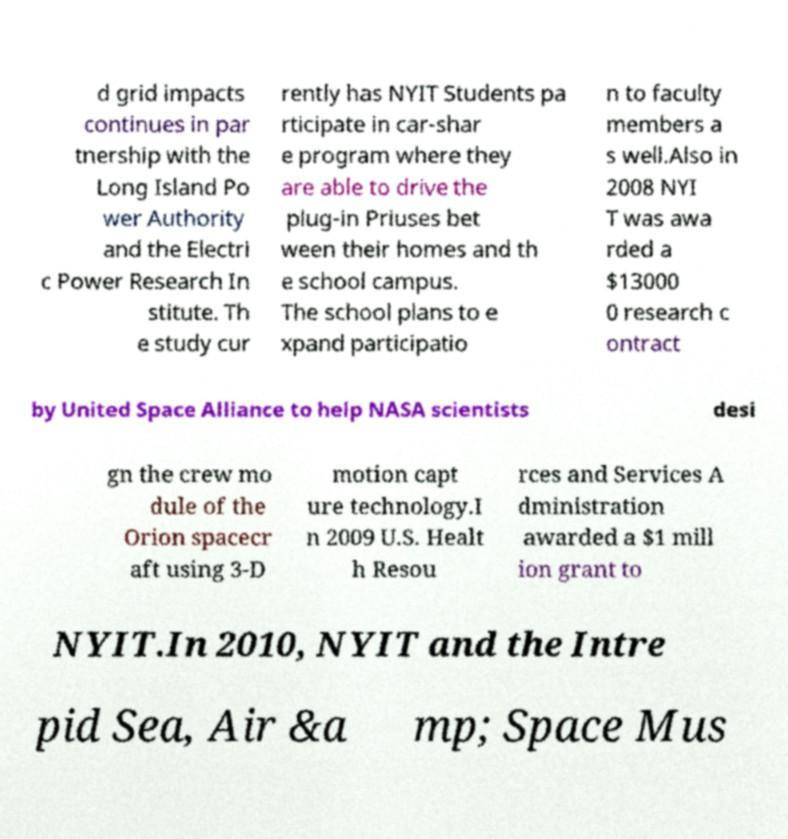Please read and relay the text visible in this image. What does it say? d grid impacts continues in par tnership with the Long Island Po wer Authority and the Electri c Power Research In stitute. Th e study cur rently has NYIT Students pa rticipate in car-shar e program where they are able to drive the plug-in Priuses bet ween their homes and th e school campus. The school plans to e xpand participatio n to faculty members a s well.Also in 2008 NYI T was awa rded a $13000 0 research c ontract by United Space Alliance to help NASA scientists desi gn the crew mo dule of the Orion spacecr aft using 3-D motion capt ure technology.I n 2009 U.S. Healt h Resou rces and Services A dministration awarded a $1 mill ion grant to NYIT.In 2010, NYIT and the Intre pid Sea, Air &a mp; Space Mus 